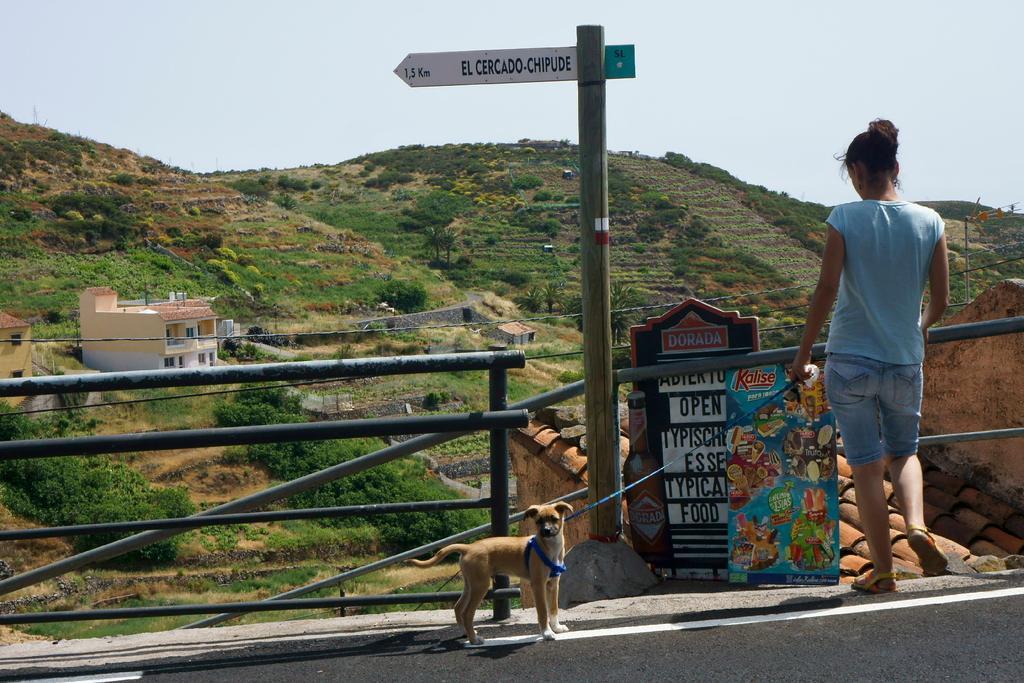Describe this image in one or two sentences. In the foreground of this image, there is a dog standing a side to a road. On right, there is a woman holding belt of that dog and behind there is a pole, railing, and two boards. In the background, there is a building, trees, wall, mountains, and the sky. 